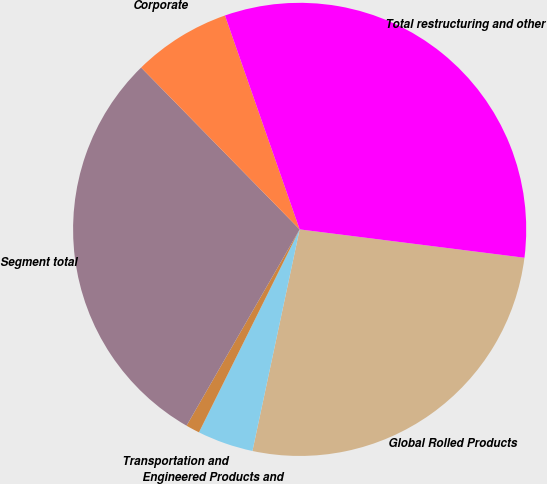<chart> <loc_0><loc_0><loc_500><loc_500><pie_chart><fcel>Global Rolled Products<fcel>Engineered Products and<fcel>Transportation and<fcel>Segment total<fcel>Corporate<fcel>Total restructuring and other<nl><fcel>26.35%<fcel>3.99%<fcel>0.99%<fcel>29.35%<fcel>6.99%<fcel>32.35%<nl></chart> 